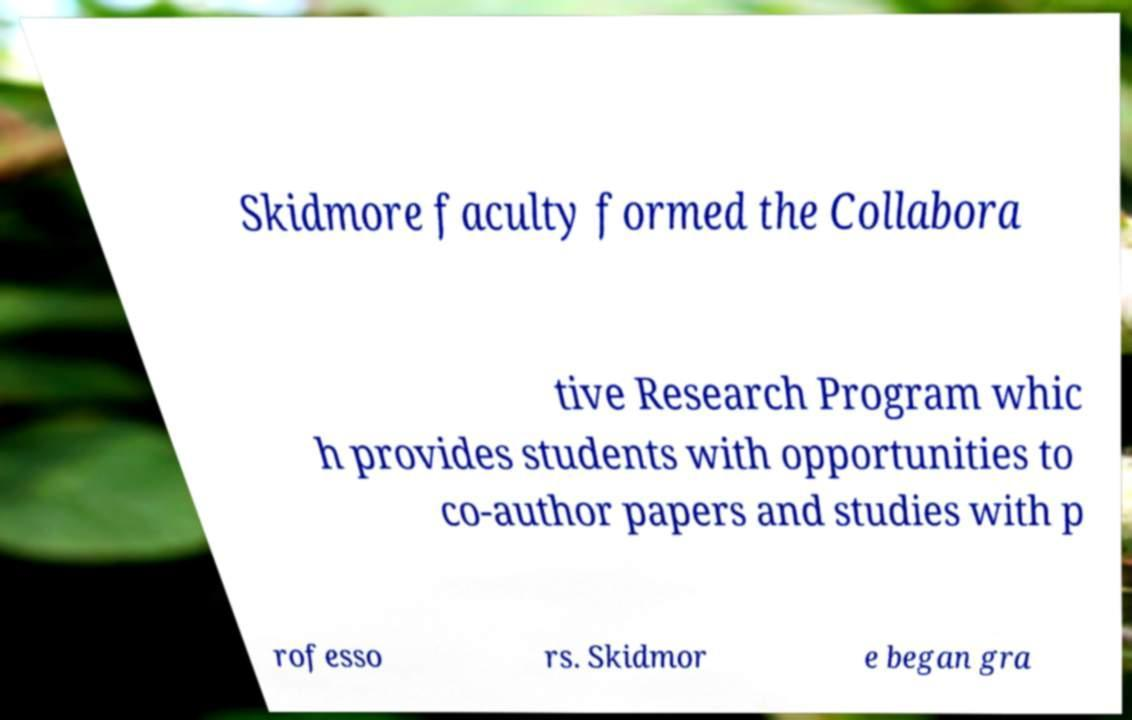Please identify and transcribe the text found in this image. Skidmore faculty formed the Collabora tive Research Program whic h provides students with opportunities to co-author papers and studies with p rofesso rs. Skidmor e began gra 